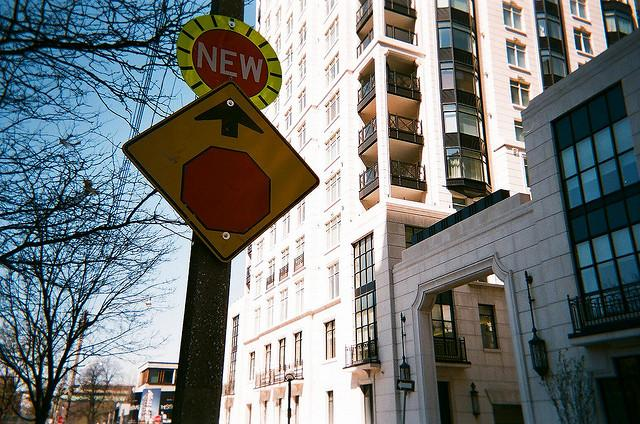The area outside the building would be described as what by a person? Please explain your reasoning. cold. The building casts a shadow. the sun can't shine where there is a shadow. 